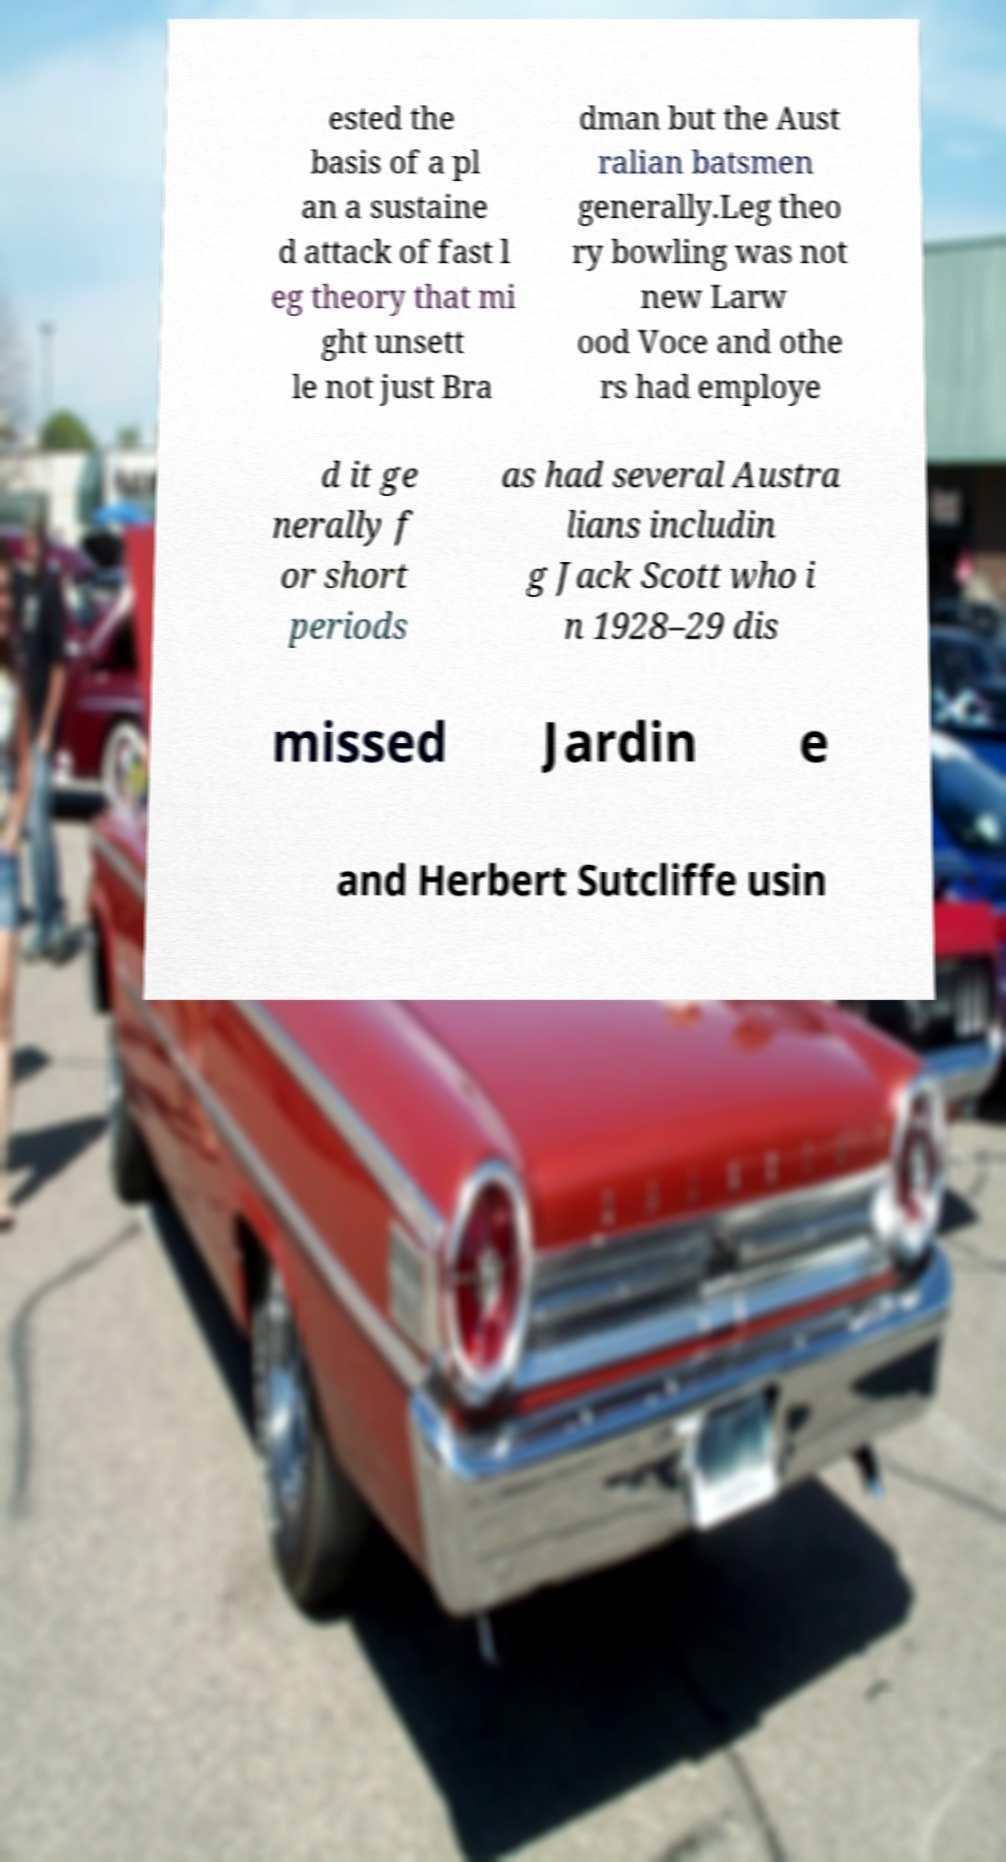For documentation purposes, I need the text within this image transcribed. Could you provide that? ested the basis of a pl an a sustaine d attack of fast l eg theory that mi ght unsett le not just Bra dman but the Aust ralian batsmen generally.Leg theo ry bowling was not new Larw ood Voce and othe rs had employe d it ge nerally f or short periods as had several Austra lians includin g Jack Scott who i n 1928–29 dis missed Jardin e and Herbert Sutcliffe usin 